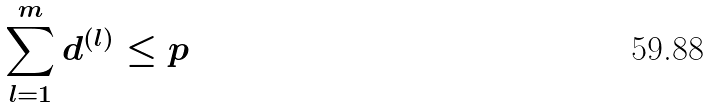<formula> <loc_0><loc_0><loc_500><loc_500>\sum _ { l = 1 } ^ { m } d ^ { ( l ) } \leq p</formula> 